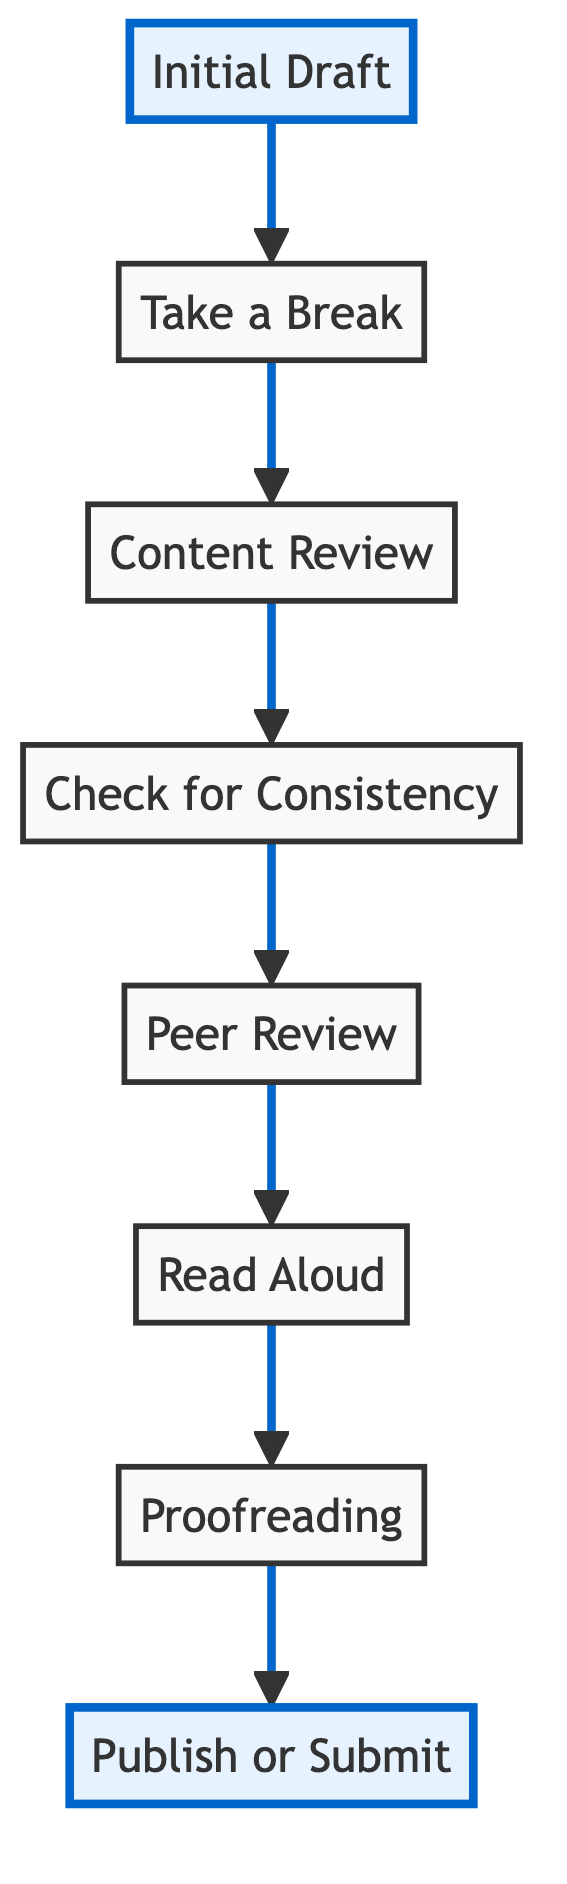What is the first step in self-editing your writing? The first step according to the diagram is "Initial Draft". It is the starting point, and all other steps follow afterward.
Answer: Initial Draft How many total steps are in the self-editing process? By counting each element in the flow chart, we find there are a total of eight steps from "Initial Draft" to "Publish or Submit".
Answer: Eight What comes after the 'Content Review'? Following the 'Content Review', the next step is 'Check for Consistency'. This indicates the flow direction in the editing process.
Answer: Check for Consistency Which step involves receiving feedback from others? The step that involves feedback from others is 'Peer Review', which directly follows the 'Check for Consistency' step in the flow.
Answer: Peer Review What is the last step in the self-editing process? The last step before completing the process is 'Publish or Submit', as it concludes the self-editing journey.
Answer: Publish or Submit Which two steps directly precede 'Proofreading'? The two steps that come just before 'Proofreading' are 'Read Aloud' and 'Peer Review', indicating a sequence where feedback and re-evaluation occur before the final check.
Answer: Read Aloud, Peer Review What should you do before starting the 'Content Review'? Before starting the 'Content Review', you should take a break as indicated by the flow chart; this allows for a fresh perspective on your writing.
Answer: Take a Break How are the steps connected in the diagram? The steps are connected in a sequential manner from the bottom to the top, with each step leading to the next in a clear progression of the self-editing process.
Answer: Sequentially connected 